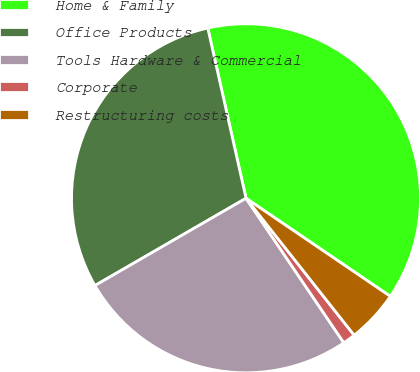Convert chart. <chart><loc_0><loc_0><loc_500><loc_500><pie_chart><fcel>Home & Family<fcel>Office Products<fcel>Tools Hardware & Commercial<fcel>Corporate<fcel>Restructuring costs<nl><fcel>38.02%<fcel>29.82%<fcel>26.13%<fcel>1.17%<fcel>4.86%<nl></chart> 